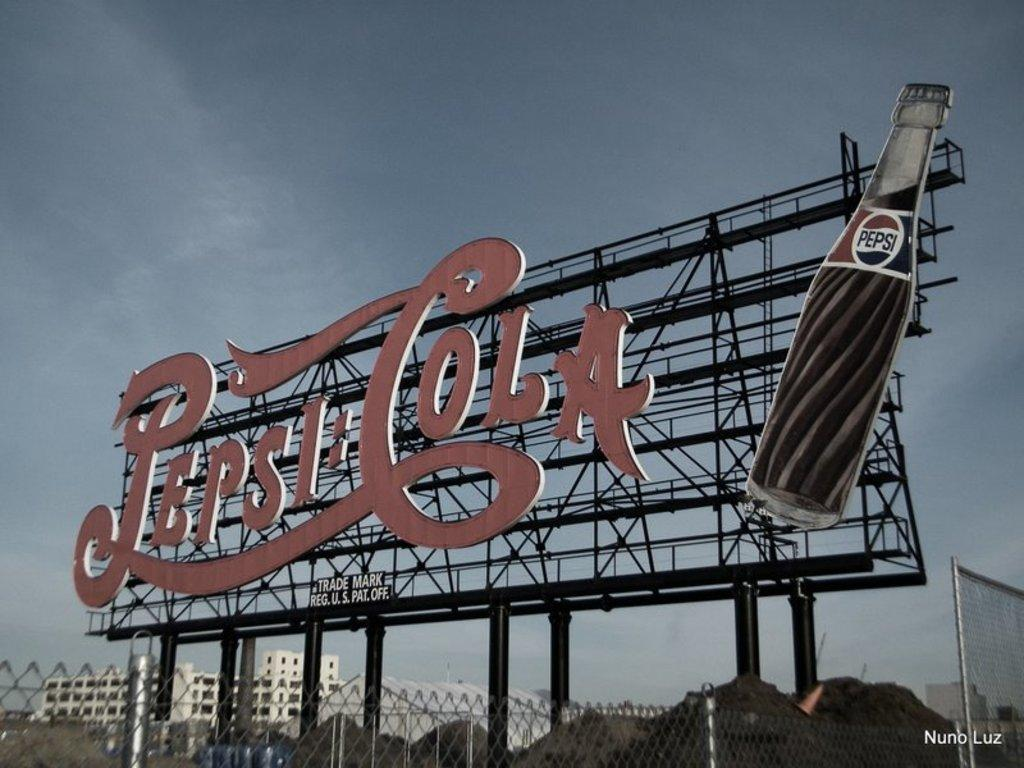Provide a one-sentence caption for the provided image. A large Pepsi Cola sign features an image of a glass soda bottle. 